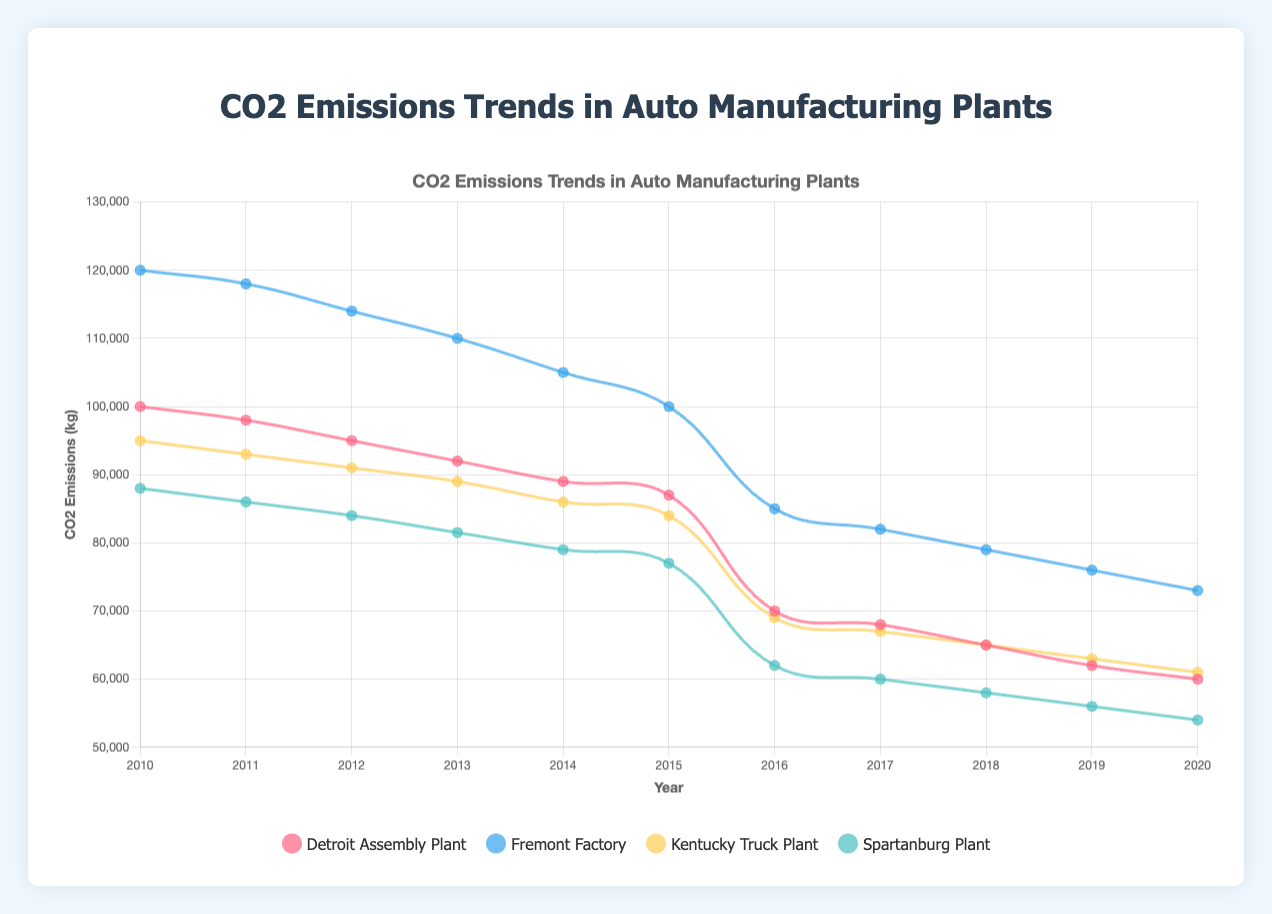What is the average CO2 emissions for the Detroit Assembly Plant before the implementation of renewable energy? First, add the CO2 emissions before 2016: 100000 + 98000 + 95000 + 92000 + 89000 + 87000 = 561000 kg CO2. Then divide by the number of years (6) to find the average: 561000 / 6 = 93500 kg CO2.
Answer: 93500 kg CO2 Which plant showed the largest reduction in CO2 emissions from 2015 to 2016? To find this, calculate the reduction for each plant: Detroit Assembly (87000 - 70000 = 17000), Fremont Factory (100000 - 85000 = 15000), Kentucky Truck (84000 - 69000 = 15000), Spartanburg (77000 - 62000 = 15000). The Detroit Assembly Plant shows the largest reduction with a value of 17000 kg CO2.
Answer: Detroit Assembly Plant From which year does the trend in CO2 emissions start decreasing for the Fremont Factory? The data shows emissions from 2010 to 2015: 120000, 118000, 114000, 110000, 105000, 100000. The decrease begins right after 2010.
Answer: 2011 What is the total CO2 emissions reduction for the Spartanburg Plant from 2016 to 2020? Calculate the reduction year by year and sum them: 62000 - 60000 = 2000, 60000 - 58000 = 2000, 58000 - 56000 = 2000, 56000 - 54000 = 2000. Summing these reductions: 2000 + 2000 + 2000 + 2000 = 8000 kg CO2.
Answer: 8000 kg CO2 Which plant had the highest CO2 emissions in 2013? Check the emissions for each plant in 2013: Detroit Assembly (92000), Fremont Factory (110000), Kentucky Truck (89000), Spartanburg (81500). The Fremont Factory had the highest emissions at 110000 kg CO2.
Answer: Fremont Factory Did the CO2 emissions for the Kentucky Truck Plant follow a decreasing trend from 2010 to 2015 and from 2016 to 2020? Verify the trend by looking at the data for respective periods. From 2010 to 2015: 95000, 93000, 91000, 89000, 86000, 84000 (decreasing). From 2016 to 2020: 69000, 67000, 65000, 63000, 61000 (decreasing). Both periods show a decreasing trend.
Answer: Yes What is the percentage reduction in CO2 emissions for the Spartanburg Plant from 2010 to 2020? Find the emissions in 2010 and 2020: 88000 and 54000. Calculate the reduction: 88000 - 54000 = 34000. Then the percentage reduction: (34000 / 88000) * 100 = approximately 38.64%.
Answer: 38.64% Which plant exhibited the most consistent rate of decrease in CO2 emissions after the implementation of renewable energy? Analyze the yearly decreases after 2015: Detroit (2000, 3000, 3000, 2000), Fremont (3000, 3000, 3000, 3000), Kentucky (2000, 2000, 2000, 2000), Spartanburg (2000, 2000, 2000, 2000). Fremont has a consistent 3000 kg decrease each year, but Kentucky and Spartanburg have consistent 2000 kg decrements each year. Since Fremont has higher consistent rate in terms of kg decrease, Fremont Factory should be selected.
Answer: Fremont Factory 